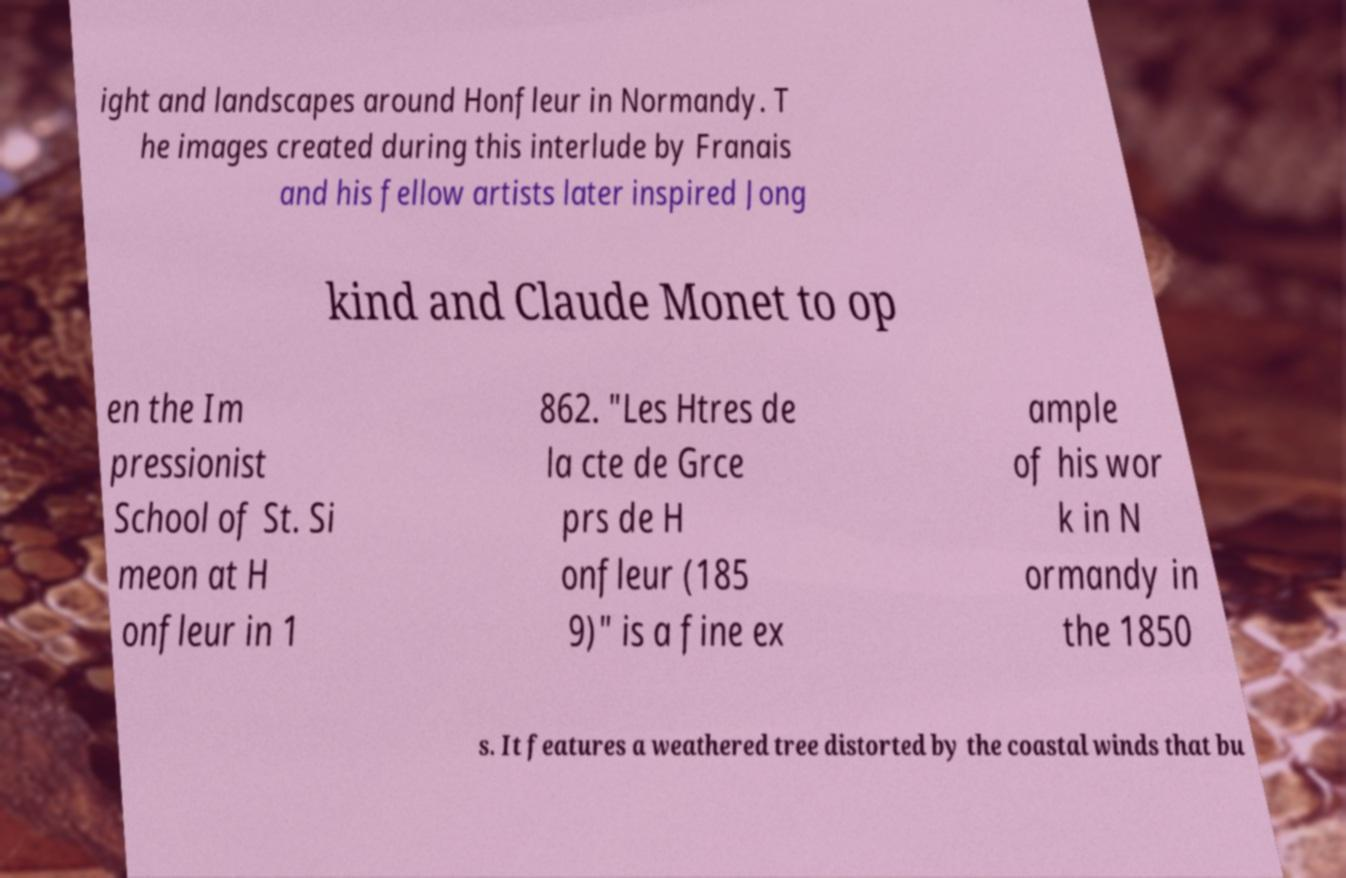Could you assist in decoding the text presented in this image and type it out clearly? ight and landscapes around Honfleur in Normandy. T he images created during this interlude by Franais and his fellow artists later inspired Jong kind and Claude Monet to op en the Im pressionist School of St. Si meon at H onfleur in 1 862. "Les Htres de la cte de Grce prs de H onfleur (185 9)" is a fine ex ample of his wor k in N ormandy in the 1850 s. It features a weathered tree distorted by the coastal winds that bu 